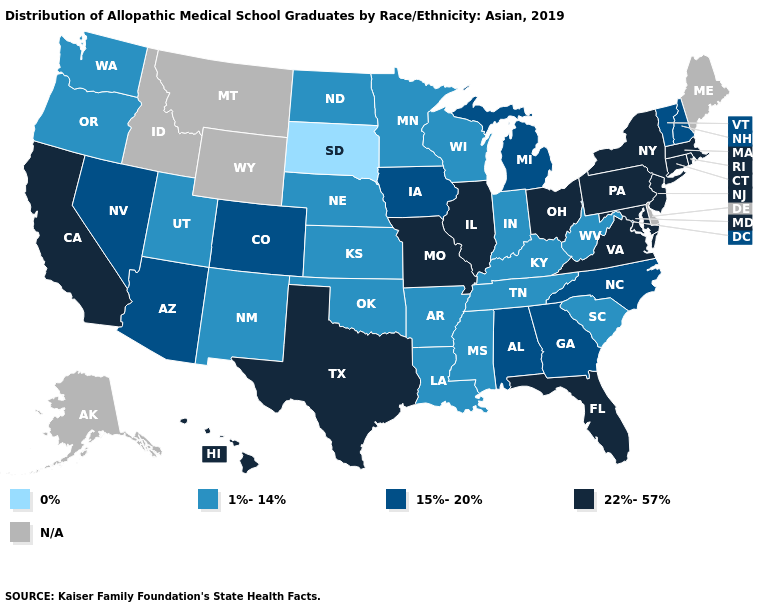What is the highest value in the South ?
Write a very short answer. 22%-57%. Among the states that border Minnesota , which have the lowest value?
Be succinct. South Dakota. What is the value of California?
Give a very brief answer. 22%-57%. Does South Dakota have the lowest value in the USA?
Quick response, please. Yes. Name the states that have a value in the range 0%?
Give a very brief answer. South Dakota. What is the value of Missouri?
Keep it brief. 22%-57%. Which states have the lowest value in the South?
Be succinct. Arkansas, Kentucky, Louisiana, Mississippi, Oklahoma, South Carolina, Tennessee, West Virginia. What is the lowest value in the South?
Quick response, please. 1%-14%. Name the states that have a value in the range N/A?
Answer briefly. Alaska, Delaware, Idaho, Maine, Montana, Wyoming. Which states have the lowest value in the West?
Write a very short answer. New Mexico, Oregon, Utah, Washington. What is the highest value in states that border Massachusetts?
Write a very short answer. 22%-57%. What is the value of Connecticut?
Give a very brief answer. 22%-57%. Does Georgia have the lowest value in the South?
Quick response, please. No. 